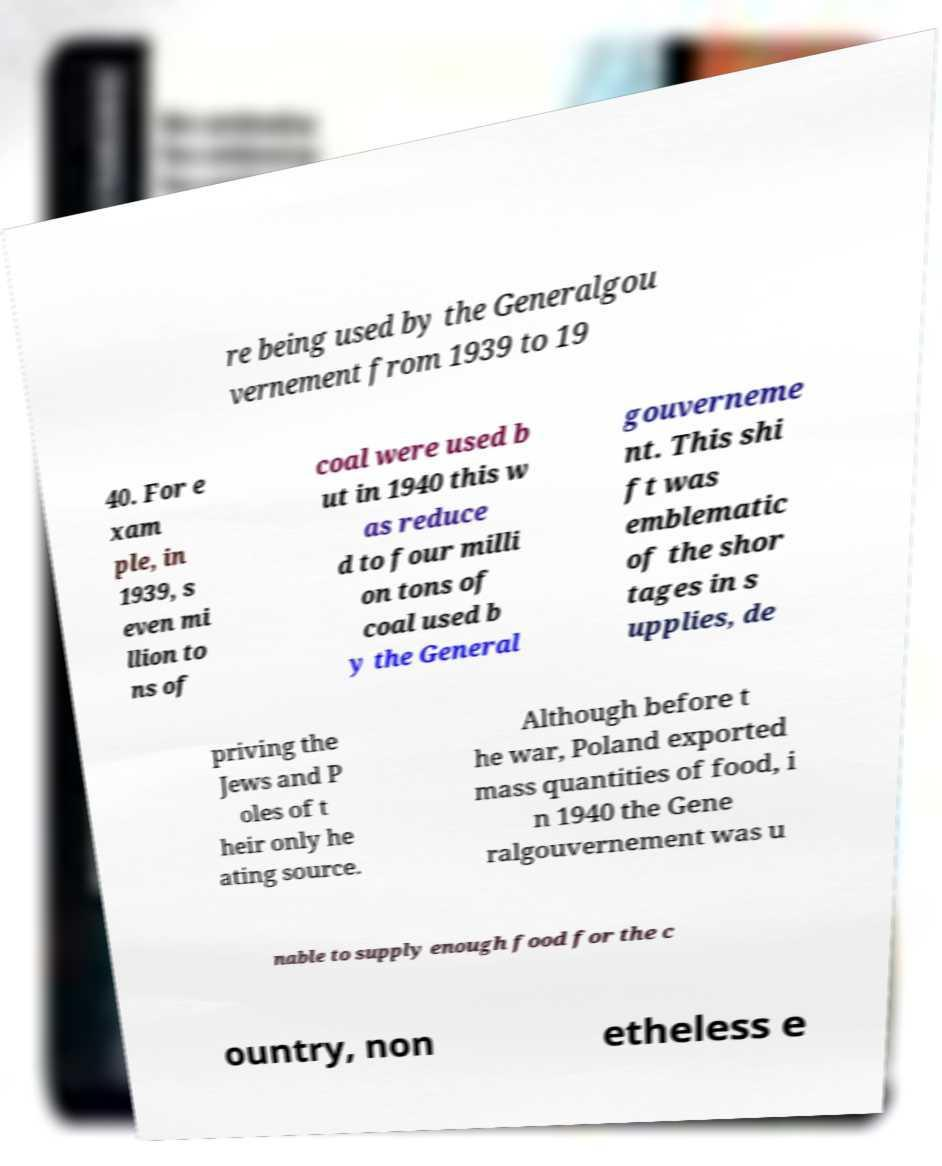There's text embedded in this image that I need extracted. Can you transcribe it verbatim? re being used by the Generalgou vernement from 1939 to 19 40. For e xam ple, in 1939, s even mi llion to ns of coal were used b ut in 1940 this w as reduce d to four milli on tons of coal used b y the General gouverneme nt. This shi ft was emblematic of the shor tages in s upplies, de priving the Jews and P oles of t heir only he ating source. Although before t he war, Poland exported mass quantities of food, i n 1940 the Gene ralgouvernement was u nable to supply enough food for the c ountry, non etheless e 